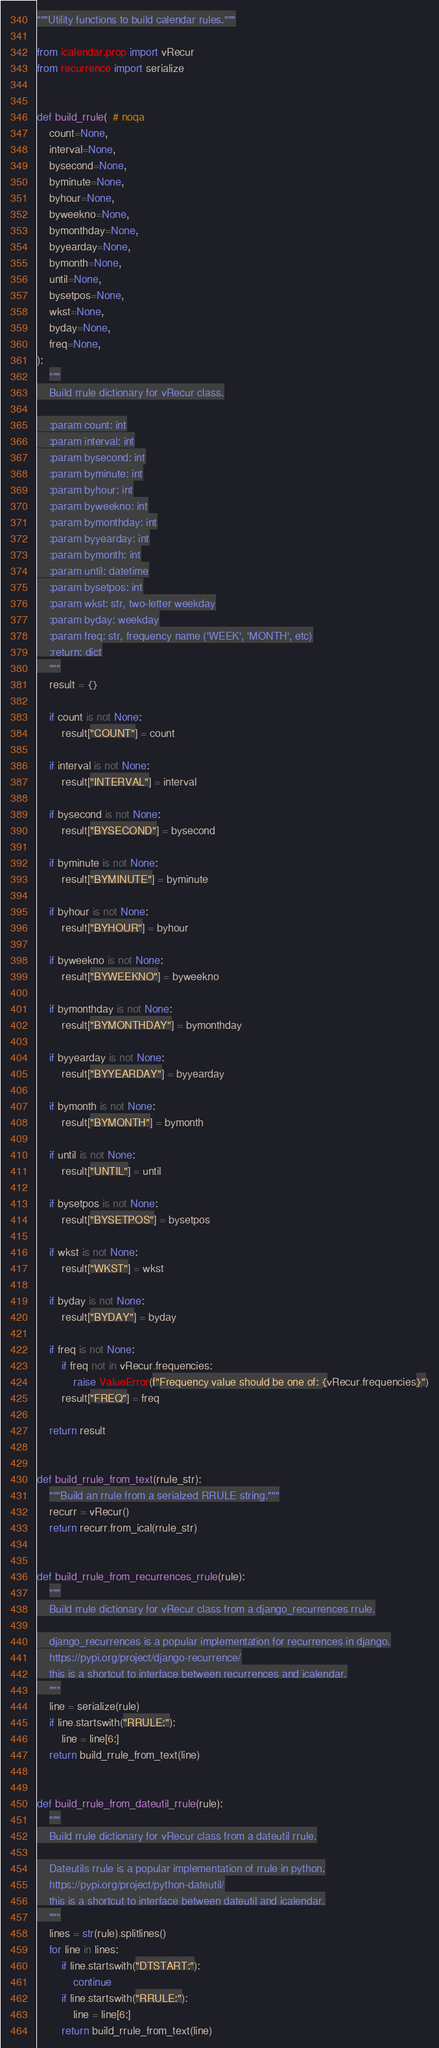<code> <loc_0><loc_0><loc_500><loc_500><_Python_>"""Utility functions to build calendar rules."""

from icalendar.prop import vRecur
from recurrence import serialize


def build_rrule(  # noqa
    count=None,
    interval=None,
    bysecond=None,
    byminute=None,
    byhour=None,
    byweekno=None,
    bymonthday=None,
    byyearday=None,
    bymonth=None,
    until=None,
    bysetpos=None,
    wkst=None,
    byday=None,
    freq=None,
):
    """
    Build rrule dictionary for vRecur class.

    :param count: int
    :param interval: int
    :param bysecond: int
    :param byminute: int
    :param byhour: int
    :param byweekno: int
    :param bymonthday: int
    :param byyearday: int
    :param bymonth: int
    :param until: datetime
    :param bysetpos: int
    :param wkst: str, two-letter weekday
    :param byday: weekday
    :param freq: str, frequency name ('WEEK', 'MONTH', etc)
    :return: dict
    """
    result = {}

    if count is not None:
        result["COUNT"] = count

    if interval is not None:
        result["INTERVAL"] = interval

    if bysecond is not None:
        result["BYSECOND"] = bysecond

    if byminute is not None:
        result["BYMINUTE"] = byminute

    if byhour is not None:
        result["BYHOUR"] = byhour

    if byweekno is not None:
        result["BYWEEKNO"] = byweekno

    if bymonthday is not None:
        result["BYMONTHDAY"] = bymonthday

    if byyearday is not None:
        result["BYYEARDAY"] = byyearday

    if bymonth is not None:
        result["BYMONTH"] = bymonth

    if until is not None:
        result["UNTIL"] = until

    if bysetpos is not None:
        result["BYSETPOS"] = bysetpos

    if wkst is not None:
        result["WKST"] = wkst

    if byday is not None:
        result["BYDAY"] = byday

    if freq is not None:
        if freq not in vRecur.frequencies:
            raise ValueError(f"Frequency value should be one of: {vRecur.frequencies}")
        result["FREQ"] = freq

    return result


def build_rrule_from_text(rrule_str):
    """Build an rrule from a serialzed RRULE string."""
    recurr = vRecur()
    return recurr.from_ical(rrule_str)


def build_rrule_from_recurrences_rrule(rule):
    """
    Build rrule dictionary for vRecur class from a django_recurrences rrule.

    django_recurrences is a popular implementation for recurrences in django.
    https://pypi.org/project/django-recurrence/
    this is a shortcut to interface between recurrences and icalendar.
    """
    line = serialize(rule)
    if line.startswith("RRULE:"):
        line = line[6:]
    return build_rrule_from_text(line)


def build_rrule_from_dateutil_rrule(rule):
    """
    Build rrule dictionary for vRecur class from a dateutil rrule.

    Dateutils rrule is a popular implementation of rrule in python.
    https://pypi.org/project/python-dateutil/
    this is a shortcut to interface between dateutil and icalendar.
    """
    lines = str(rule).splitlines()
    for line in lines:
        if line.startswith("DTSTART:"):
            continue
        if line.startswith("RRULE:"):
            line = line[6:]
        return build_rrule_from_text(line)
</code> 